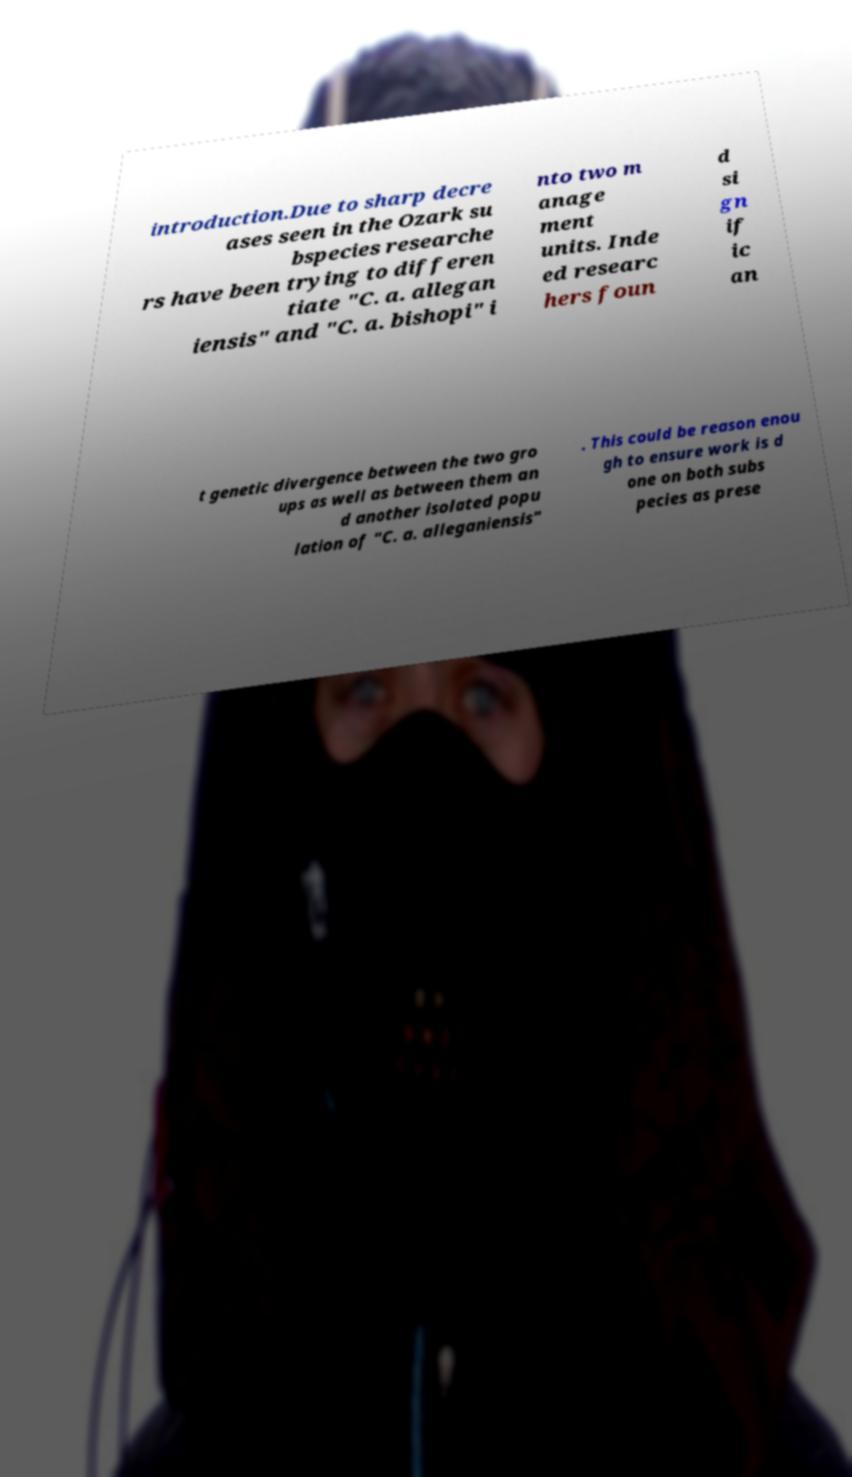Could you assist in decoding the text presented in this image and type it out clearly? introduction.Due to sharp decre ases seen in the Ozark su bspecies researche rs have been trying to differen tiate "C. a. allegan iensis" and "C. a. bishopi" i nto two m anage ment units. Inde ed researc hers foun d si gn if ic an t genetic divergence between the two gro ups as well as between them an d another isolated popu lation of "C. a. alleganiensis" . This could be reason enou gh to ensure work is d one on both subs pecies as prese 